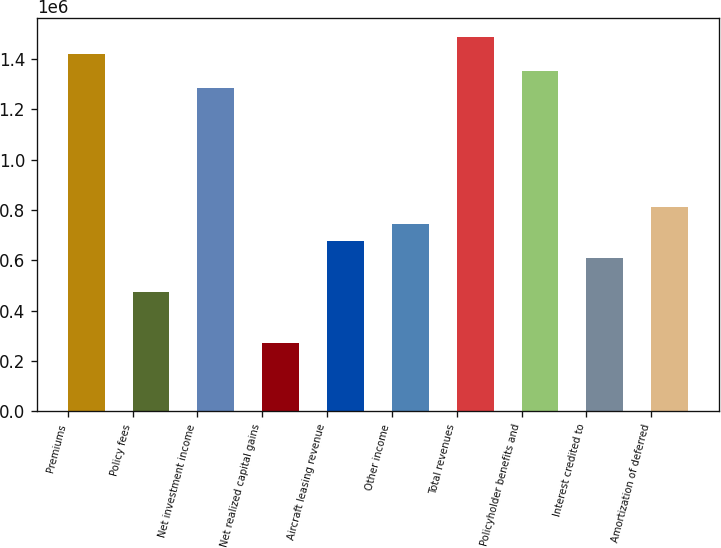<chart> <loc_0><loc_0><loc_500><loc_500><bar_chart><fcel>Premiums<fcel>Policy fees<fcel>Net investment income<fcel>Net realized capital gains<fcel>Aircraft leasing revenue<fcel>Other income<fcel>Total revenues<fcel>Policyholder benefits and<fcel>Interest credited to<fcel>Amortization of deferred<nl><fcel>1.41857e+06<fcel>472936<fcel>1.28348e+06<fcel>270299<fcel>675573<fcel>743119<fcel>1.48612e+06<fcel>1.35103e+06<fcel>608027<fcel>810664<nl></chart> 